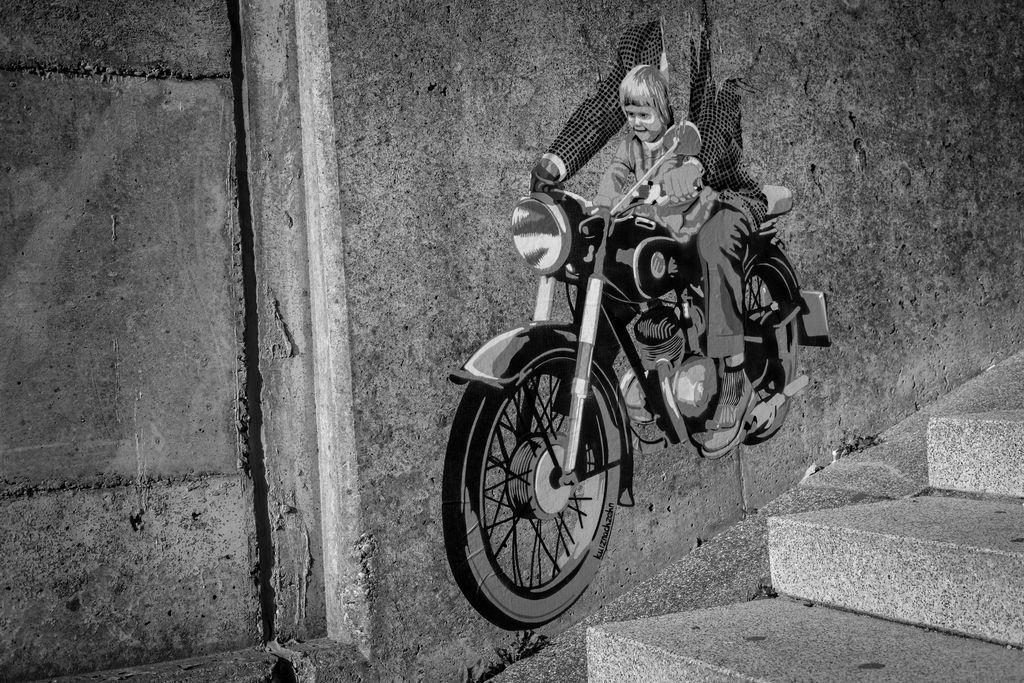What type of artwork is displayed on the wall in the image? There is a black and white picture of a painting on the wall. What is the subject matter of the painting? The painting depicts two people sitting on a motorcycle. What architectural feature is visible on the right side of the image? There is a staircase to the right side of the image. Where is the hook located in the image? There is no hook present in the image. What type of drain can be seen in the image? There is no drain present in the image. 